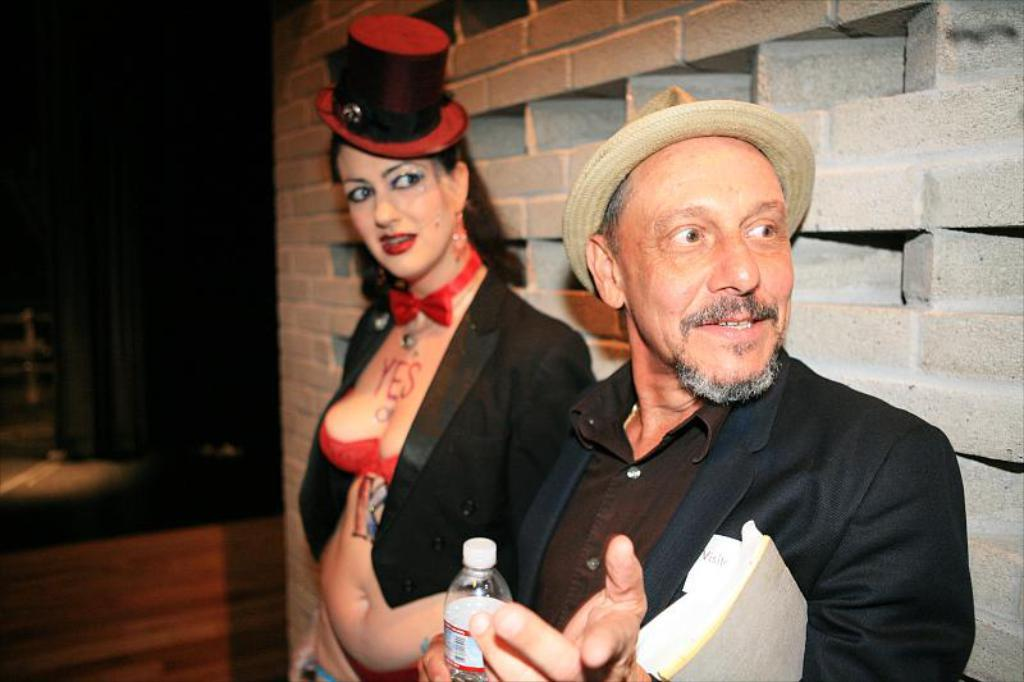What is the person in the foreground holding in the image? The person is holding a book and a water bottle. Can you describe the second person in the image? There is another person standing in the background. What can be seen in the background of the image? There is a wall visible in the background. What type of feather can be seen falling from the sky in the image? There is no feather falling from the sky in the image. How does the person in the foreground feel about their recent loss in the image? There is no indication of any loss or emotional state in the image. 